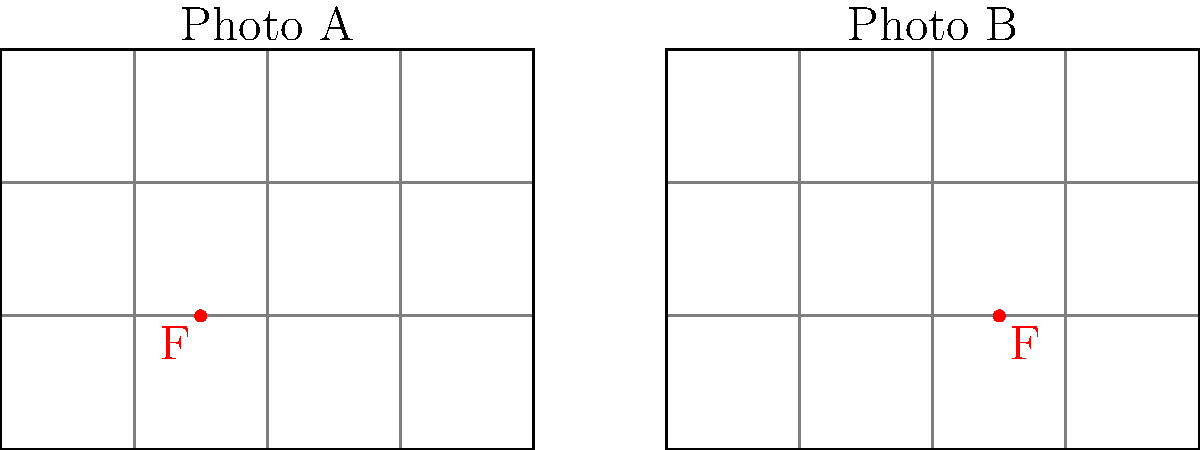As a seasoned photographer, analyze the composition of the two landscape photographs represented by the grids above. Which photograph adheres more closely to the rule of thirds, and why? To determine which photograph adheres more closely to the rule of thirds, we need to examine the placement of the focal point (F) in each image:

1. The rule of thirds divides an image into a 3x3 grid, creating four intersection points.
2. According to this rule, important elements should be placed along these lines or at their intersections.

For Photo A:
3. The focal point F is located at (1.5, 1) on the grid.
4. This point is not exactly on a third line or intersection point.
5. It's slightly off-center but not aligned with the rule of thirds.

For Photo B:
6. The focal point F is located at (2.5, 1) on its respective grid.
7. This point falls exactly on the left vertical third line.
8. It's also close to the lower horizontal third line.

9. Comparing the two, Photo B's focal point aligns more closely with the rule of thirds grid.
10. The focal point in Photo B is precisely on a third line, while in Photo A it's not on any third line or intersection.

Therefore, Photo B adheres more closely to the rule of thirds.
Answer: Photo B 